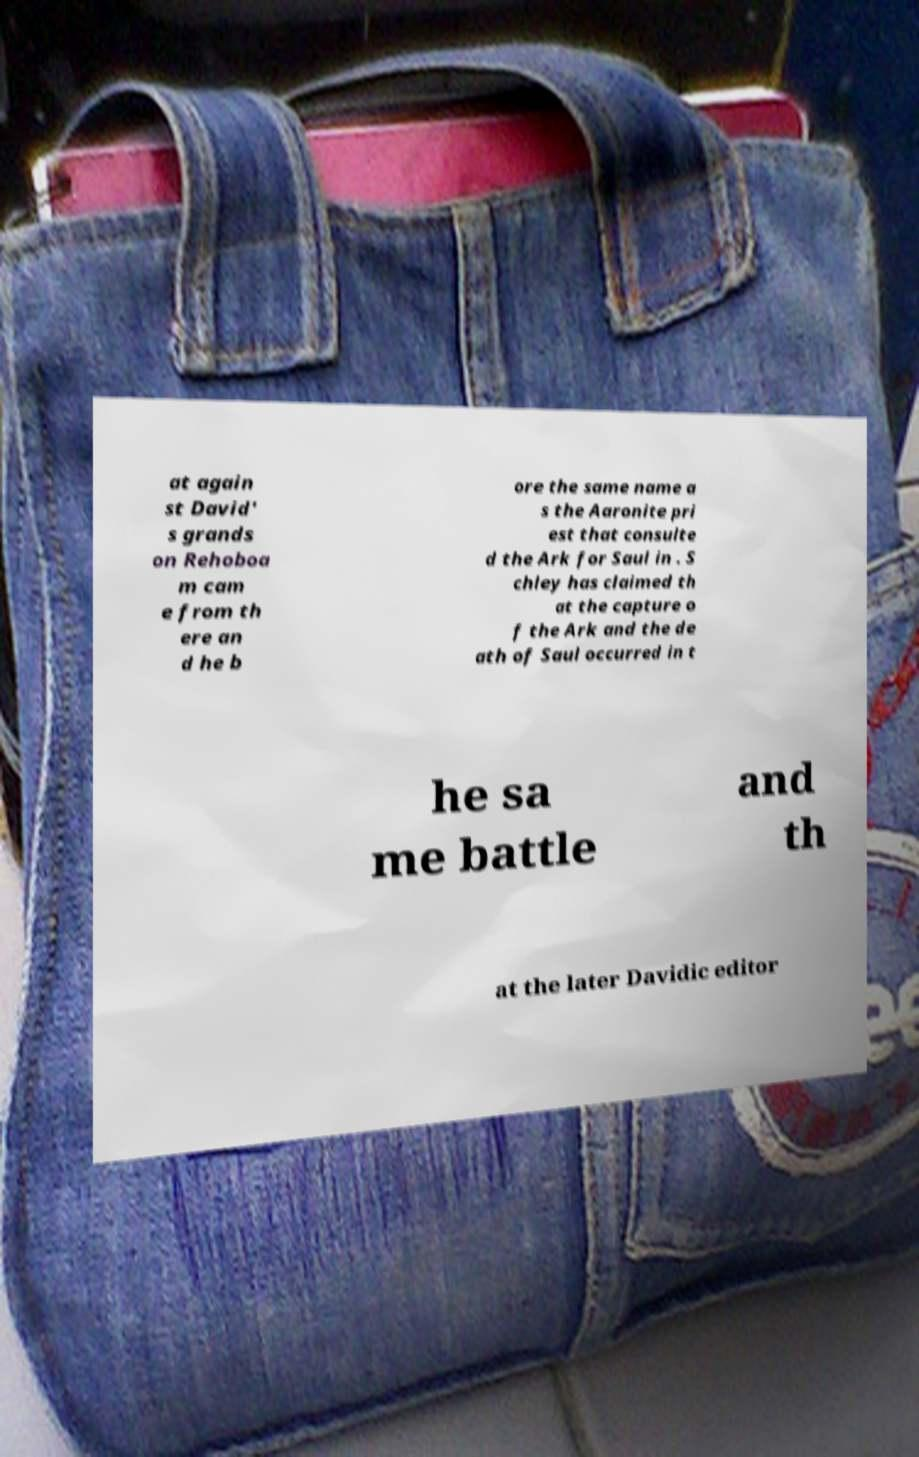I need the written content from this picture converted into text. Can you do that? at again st David' s grands on Rehoboa m cam e from th ere an d he b ore the same name a s the Aaronite pri est that consulte d the Ark for Saul in . S chley has claimed th at the capture o f the Ark and the de ath of Saul occurred in t he sa me battle and th at the later Davidic editor 